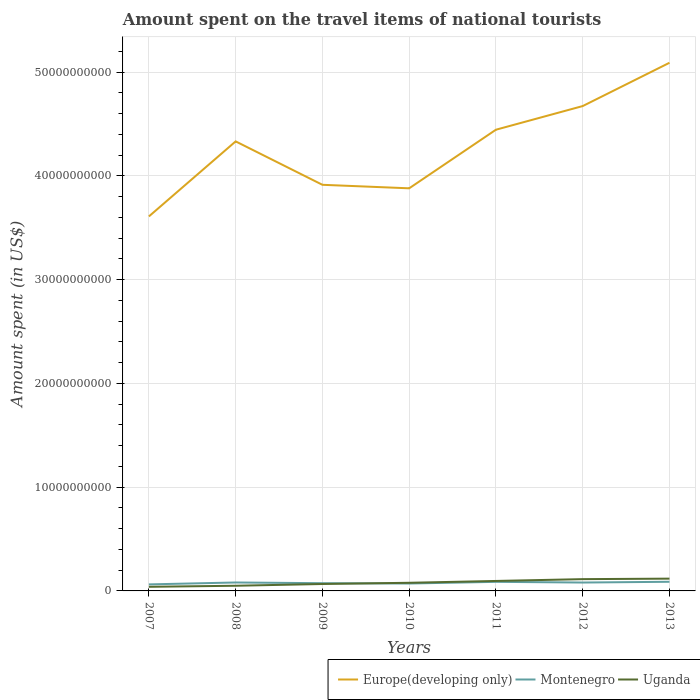Across all years, what is the maximum amount spent on the travel items of national tourists in Uganda?
Provide a short and direct response. 3.98e+08. In which year was the amount spent on the travel items of national tourists in Europe(developing only) maximum?
Provide a succinct answer. 2007. What is the total amount spent on the travel items of national tourists in Montenegro in the graph?
Provide a succinct answer. 6.60e+07. What is the difference between the highest and the second highest amount spent on the travel items of national tourists in Montenegro?
Provide a succinct answer. 2.50e+08. Is the amount spent on the travel items of national tourists in Uganda strictly greater than the amount spent on the travel items of national tourists in Montenegro over the years?
Provide a short and direct response. No. How many lines are there?
Offer a terse response. 3. How many years are there in the graph?
Ensure brevity in your answer.  7. What is the difference between two consecutive major ticks on the Y-axis?
Provide a succinct answer. 1.00e+1. Are the values on the major ticks of Y-axis written in scientific E-notation?
Provide a short and direct response. No. Does the graph contain any zero values?
Give a very brief answer. No. Does the graph contain grids?
Provide a succinct answer. Yes. How are the legend labels stacked?
Provide a short and direct response. Horizontal. What is the title of the graph?
Ensure brevity in your answer.  Amount spent on the travel items of national tourists. What is the label or title of the X-axis?
Provide a succinct answer. Years. What is the label or title of the Y-axis?
Your answer should be compact. Amount spent (in US$). What is the Amount spent (in US$) of Europe(developing only) in 2007?
Ensure brevity in your answer.  3.61e+1. What is the Amount spent (in US$) of Montenegro in 2007?
Your answer should be very brief. 6.30e+08. What is the Amount spent (in US$) in Uganda in 2007?
Offer a terse response. 3.98e+08. What is the Amount spent (in US$) of Europe(developing only) in 2008?
Your answer should be compact. 4.33e+1. What is the Amount spent (in US$) in Montenegro in 2008?
Your answer should be compact. 8.13e+08. What is the Amount spent (in US$) in Uganda in 2008?
Provide a short and direct response. 4.98e+08. What is the Amount spent (in US$) of Europe(developing only) in 2009?
Offer a very short reply. 3.91e+1. What is the Amount spent (in US$) in Montenegro in 2009?
Your answer should be very brief. 7.45e+08. What is the Amount spent (in US$) of Uganda in 2009?
Offer a terse response. 6.67e+08. What is the Amount spent (in US$) of Europe(developing only) in 2010?
Keep it short and to the point. 3.88e+1. What is the Amount spent (in US$) in Montenegro in 2010?
Your response must be concise. 7.13e+08. What is the Amount spent (in US$) of Uganda in 2010?
Offer a very short reply. 7.84e+08. What is the Amount spent (in US$) in Europe(developing only) in 2011?
Offer a terse response. 4.44e+1. What is the Amount spent (in US$) in Montenegro in 2011?
Offer a terse response. 8.75e+08. What is the Amount spent (in US$) of Uganda in 2011?
Provide a succinct answer. 9.60e+08. What is the Amount spent (in US$) of Europe(developing only) in 2012?
Your answer should be compact. 4.67e+1. What is the Amount spent (in US$) of Montenegro in 2012?
Your answer should be compact. 8.09e+08. What is the Amount spent (in US$) in Uganda in 2012?
Your answer should be very brief. 1.14e+09. What is the Amount spent (in US$) in Europe(developing only) in 2013?
Make the answer very short. 5.09e+1. What is the Amount spent (in US$) of Montenegro in 2013?
Ensure brevity in your answer.  8.80e+08. What is the Amount spent (in US$) in Uganda in 2013?
Keep it short and to the point. 1.18e+09. Across all years, what is the maximum Amount spent (in US$) of Europe(developing only)?
Provide a short and direct response. 5.09e+1. Across all years, what is the maximum Amount spent (in US$) in Montenegro?
Your response must be concise. 8.80e+08. Across all years, what is the maximum Amount spent (in US$) in Uganda?
Offer a terse response. 1.18e+09. Across all years, what is the minimum Amount spent (in US$) of Europe(developing only)?
Ensure brevity in your answer.  3.61e+1. Across all years, what is the minimum Amount spent (in US$) in Montenegro?
Give a very brief answer. 6.30e+08. Across all years, what is the minimum Amount spent (in US$) in Uganda?
Offer a very short reply. 3.98e+08. What is the total Amount spent (in US$) in Europe(developing only) in the graph?
Keep it short and to the point. 2.99e+11. What is the total Amount spent (in US$) in Montenegro in the graph?
Your response must be concise. 5.46e+09. What is the total Amount spent (in US$) in Uganda in the graph?
Make the answer very short. 5.63e+09. What is the difference between the Amount spent (in US$) in Europe(developing only) in 2007 and that in 2008?
Keep it short and to the point. -7.23e+09. What is the difference between the Amount spent (in US$) in Montenegro in 2007 and that in 2008?
Ensure brevity in your answer.  -1.83e+08. What is the difference between the Amount spent (in US$) of Uganda in 2007 and that in 2008?
Provide a short and direct response. -1.00e+08. What is the difference between the Amount spent (in US$) in Europe(developing only) in 2007 and that in 2009?
Your response must be concise. -3.05e+09. What is the difference between the Amount spent (in US$) in Montenegro in 2007 and that in 2009?
Ensure brevity in your answer.  -1.15e+08. What is the difference between the Amount spent (in US$) of Uganda in 2007 and that in 2009?
Offer a terse response. -2.69e+08. What is the difference between the Amount spent (in US$) of Europe(developing only) in 2007 and that in 2010?
Give a very brief answer. -2.71e+09. What is the difference between the Amount spent (in US$) of Montenegro in 2007 and that in 2010?
Your answer should be compact. -8.30e+07. What is the difference between the Amount spent (in US$) of Uganda in 2007 and that in 2010?
Offer a very short reply. -3.86e+08. What is the difference between the Amount spent (in US$) of Europe(developing only) in 2007 and that in 2011?
Make the answer very short. -8.36e+09. What is the difference between the Amount spent (in US$) of Montenegro in 2007 and that in 2011?
Keep it short and to the point. -2.45e+08. What is the difference between the Amount spent (in US$) in Uganda in 2007 and that in 2011?
Make the answer very short. -5.62e+08. What is the difference between the Amount spent (in US$) of Europe(developing only) in 2007 and that in 2012?
Your answer should be compact. -1.06e+1. What is the difference between the Amount spent (in US$) in Montenegro in 2007 and that in 2012?
Offer a very short reply. -1.79e+08. What is the difference between the Amount spent (in US$) in Uganda in 2007 and that in 2012?
Offer a very short reply. -7.37e+08. What is the difference between the Amount spent (in US$) of Europe(developing only) in 2007 and that in 2013?
Your response must be concise. -1.48e+1. What is the difference between the Amount spent (in US$) of Montenegro in 2007 and that in 2013?
Your response must be concise. -2.50e+08. What is the difference between the Amount spent (in US$) of Uganda in 2007 and that in 2013?
Your answer should be very brief. -7.86e+08. What is the difference between the Amount spent (in US$) of Europe(developing only) in 2008 and that in 2009?
Offer a terse response. 4.18e+09. What is the difference between the Amount spent (in US$) of Montenegro in 2008 and that in 2009?
Make the answer very short. 6.80e+07. What is the difference between the Amount spent (in US$) of Uganda in 2008 and that in 2009?
Your answer should be very brief. -1.69e+08. What is the difference between the Amount spent (in US$) of Europe(developing only) in 2008 and that in 2010?
Make the answer very short. 4.52e+09. What is the difference between the Amount spent (in US$) of Montenegro in 2008 and that in 2010?
Your response must be concise. 1.00e+08. What is the difference between the Amount spent (in US$) of Uganda in 2008 and that in 2010?
Your answer should be compact. -2.86e+08. What is the difference between the Amount spent (in US$) in Europe(developing only) in 2008 and that in 2011?
Your response must be concise. -1.12e+09. What is the difference between the Amount spent (in US$) of Montenegro in 2008 and that in 2011?
Your response must be concise. -6.20e+07. What is the difference between the Amount spent (in US$) in Uganda in 2008 and that in 2011?
Your response must be concise. -4.62e+08. What is the difference between the Amount spent (in US$) in Europe(developing only) in 2008 and that in 2012?
Make the answer very short. -3.40e+09. What is the difference between the Amount spent (in US$) in Uganda in 2008 and that in 2012?
Your answer should be very brief. -6.37e+08. What is the difference between the Amount spent (in US$) of Europe(developing only) in 2008 and that in 2013?
Provide a short and direct response. -7.57e+09. What is the difference between the Amount spent (in US$) in Montenegro in 2008 and that in 2013?
Provide a short and direct response. -6.70e+07. What is the difference between the Amount spent (in US$) in Uganda in 2008 and that in 2013?
Offer a very short reply. -6.86e+08. What is the difference between the Amount spent (in US$) of Europe(developing only) in 2009 and that in 2010?
Offer a terse response. 3.38e+08. What is the difference between the Amount spent (in US$) of Montenegro in 2009 and that in 2010?
Ensure brevity in your answer.  3.20e+07. What is the difference between the Amount spent (in US$) of Uganda in 2009 and that in 2010?
Make the answer very short. -1.17e+08. What is the difference between the Amount spent (in US$) of Europe(developing only) in 2009 and that in 2011?
Make the answer very short. -5.31e+09. What is the difference between the Amount spent (in US$) in Montenegro in 2009 and that in 2011?
Your answer should be compact. -1.30e+08. What is the difference between the Amount spent (in US$) of Uganda in 2009 and that in 2011?
Offer a terse response. -2.93e+08. What is the difference between the Amount spent (in US$) of Europe(developing only) in 2009 and that in 2012?
Provide a succinct answer. -7.59e+09. What is the difference between the Amount spent (in US$) of Montenegro in 2009 and that in 2012?
Your answer should be very brief. -6.40e+07. What is the difference between the Amount spent (in US$) in Uganda in 2009 and that in 2012?
Keep it short and to the point. -4.68e+08. What is the difference between the Amount spent (in US$) of Europe(developing only) in 2009 and that in 2013?
Your answer should be compact. -1.18e+1. What is the difference between the Amount spent (in US$) of Montenegro in 2009 and that in 2013?
Provide a short and direct response. -1.35e+08. What is the difference between the Amount spent (in US$) in Uganda in 2009 and that in 2013?
Give a very brief answer. -5.17e+08. What is the difference between the Amount spent (in US$) of Europe(developing only) in 2010 and that in 2011?
Your answer should be very brief. -5.65e+09. What is the difference between the Amount spent (in US$) in Montenegro in 2010 and that in 2011?
Provide a short and direct response. -1.62e+08. What is the difference between the Amount spent (in US$) in Uganda in 2010 and that in 2011?
Ensure brevity in your answer.  -1.76e+08. What is the difference between the Amount spent (in US$) in Europe(developing only) in 2010 and that in 2012?
Offer a very short reply. -7.92e+09. What is the difference between the Amount spent (in US$) in Montenegro in 2010 and that in 2012?
Offer a very short reply. -9.60e+07. What is the difference between the Amount spent (in US$) in Uganda in 2010 and that in 2012?
Provide a succinct answer. -3.51e+08. What is the difference between the Amount spent (in US$) in Europe(developing only) in 2010 and that in 2013?
Keep it short and to the point. -1.21e+1. What is the difference between the Amount spent (in US$) of Montenegro in 2010 and that in 2013?
Provide a short and direct response. -1.67e+08. What is the difference between the Amount spent (in US$) in Uganda in 2010 and that in 2013?
Offer a very short reply. -4.00e+08. What is the difference between the Amount spent (in US$) in Europe(developing only) in 2011 and that in 2012?
Offer a very short reply. -2.28e+09. What is the difference between the Amount spent (in US$) in Montenegro in 2011 and that in 2012?
Provide a succinct answer. 6.60e+07. What is the difference between the Amount spent (in US$) in Uganda in 2011 and that in 2012?
Make the answer very short. -1.75e+08. What is the difference between the Amount spent (in US$) in Europe(developing only) in 2011 and that in 2013?
Offer a very short reply. -6.45e+09. What is the difference between the Amount spent (in US$) in Montenegro in 2011 and that in 2013?
Your response must be concise. -5.00e+06. What is the difference between the Amount spent (in US$) of Uganda in 2011 and that in 2013?
Offer a terse response. -2.24e+08. What is the difference between the Amount spent (in US$) of Europe(developing only) in 2012 and that in 2013?
Your answer should be compact. -4.17e+09. What is the difference between the Amount spent (in US$) in Montenegro in 2012 and that in 2013?
Provide a short and direct response. -7.10e+07. What is the difference between the Amount spent (in US$) of Uganda in 2012 and that in 2013?
Provide a succinct answer. -4.90e+07. What is the difference between the Amount spent (in US$) in Europe(developing only) in 2007 and the Amount spent (in US$) in Montenegro in 2008?
Your response must be concise. 3.53e+1. What is the difference between the Amount spent (in US$) of Europe(developing only) in 2007 and the Amount spent (in US$) of Uganda in 2008?
Make the answer very short. 3.56e+1. What is the difference between the Amount spent (in US$) in Montenegro in 2007 and the Amount spent (in US$) in Uganda in 2008?
Make the answer very short. 1.32e+08. What is the difference between the Amount spent (in US$) in Europe(developing only) in 2007 and the Amount spent (in US$) in Montenegro in 2009?
Give a very brief answer. 3.53e+1. What is the difference between the Amount spent (in US$) of Europe(developing only) in 2007 and the Amount spent (in US$) of Uganda in 2009?
Your answer should be compact. 3.54e+1. What is the difference between the Amount spent (in US$) in Montenegro in 2007 and the Amount spent (in US$) in Uganda in 2009?
Provide a succinct answer. -3.70e+07. What is the difference between the Amount spent (in US$) in Europe(developing only) in 2007 and the Amount spent (in US$) in Montenegro in 2010?
Give a very brief answer. 3.54e+1. What is the difference between the Amount spent (in US$) in Europe(developing only) in 2007 and the Amount spent (in US$) in Uganda in 2010?
Provide a short and direct response. 3.53e+1. What is the difference between the Amount spent (in US$) in Montenegro in 2007 and the Amount spent (in US$) in Uganda in 2010?
Make the answer very short. -1.54e+08. What is the difference between the Amount spent (in US$) in Europe(developing only) in 2007 and the Amount spent (in US$) in Montenegro in 2011?
Provide a short and direct response. 3.52e+1. What is the difference between the Amount spent (in US$) of Europe(developing only) in 2007 and the Amount spent (in US$) of Uganda in 2011?
Make the answer very short. 3.51e+1. What is the difference between the Amount spent (in US$) of Montenegro in 2007 and the Amount spent (in US$) of Uganda in 2011?
Give a very brief answer. -3.30e+08. What is the difference between the Amount spent (in US$) in Europe(developing only) in 2007 and the Amount spent (in US$) in Montenegro in 2012?
Offer a very short reply. 3.53e+1. What is the difference between the Amount spent (in US$) of Europe(developing only) in 2007 and the Amount spent (in US$) of Uganda in 2012?
Offer a very short reply. 3.49e+1. What is the difference between the Amount spent (in US$) of Montenegro in 2007 and the Amount spent (in US$) of Uganda in 2012?
Offer a very short reply. -5.05e+08. What is the difference between the Amount spent (in US$) in Europe(developing only) in 2007 and the Amount spent (in US$) in Montenegro in 2013?
Ensure brevity in your answer.  3.52e+1. What is the difference between the Amount spent (in US$) of Europe(developing only) in 2007 and the Amount spent (in US$) of Uganda in 2013?
Offer a very short reply. 3.49e+1. What is the difference between the Amount spent (in US$) in Montenegro in 2007 and the Amount spent (in US$) in Uganda in 2013?
Offer a terse response. -5.54e+08. What is the difference between the Amount spent (in US$) in Europe(developing only) in 2008 and the Amount spent (in US$) in Montenegro in 2009?
Give a very brief answer. 4.26e+1. What is the difference between the Amount spent (in US$) in Europe(developing only) in 2008 and the Amount spent (in US$) in Uganda in 2009?
Provide a short and direct response. 4.26e+1. What is the difference between the Amount spent (in US$) in Montenegro in 2008 and the Amount spent (in US$) in Uganda in 2009?
Make the answer very short. 1.46e+08. What is the difference between the Amount spent (in US$) in Europe(developing only) in 2008 and the Amount spent (in US$) in Montenegro in 2010?
Ensure brevity in your answer.  4.26e+1. What is the difference between the Amount spent (in US$) of Europe(developing only) in 2008 and the Amount spent (in US$) of Uganda in 2010?
Keep it short and to the point. 4.25e+1. What is the difference between the Amount spent (in US$) of Montenegro in 2008 and the Amount spent (in US$) of Uganda in 2010?
Offer a terse response. 2.90e+07. What is the difference between the Amount spent (in US$) in Europe(developing only) in 2008 and the Amount spent (in US$) in Montenegro in 2011?
Keep it short and to the point. 4.24e+1. What is the difference between the Amount spent (in US$) in Europe(developing only) in 2008 and the Amount spent (in US$) in Uganda in 2011?
Keep it short and to the point. 4.24e+1. What is the difference between the Amount spent (in US$) of Montenegro in 2008 and the Amount spent (in US$) of Uganda in 2011?
Provide a short and direct response. -1.47e+08. What is the difference between the Amount spent (in US$) of Europe(developing only) in 2008 and the Amount spent (in US$) of Montenegro in 2012?
Make the answer very short. 4.25e+1. What is the difference between the Amount spent (in US$) in Europe(developing only) in 2008 and the Amount spent (in US$) in Uganda in 2012?
Make the answer very short. 4.22e+1. What is the difference between the Amount spent (in US$) of Montenegro in 2008 and the Amount spent (in US$) of Uganda in 2012?
Provide a short and direct response. -3.22e+08. What is the difference between the Amount spent (in US$) in Europe(developing only) in 2008 and the Amount spent (in US$) in Montenegro in 2013?
Provide a short and direct response. 4.24e+1. What is the difference between the Amount spent (in US$) of Europe(developing only) in 2008 and the Amount spent (in US$) of Uganda in 2013?
Keep it short and to the point. 4.21e+1. What is the difference between the Amount spent (in US$) in Montenegro in 2008 and the Amount spent (in US$) in Uganda in 2013?
Keep it short and to the point. -3.71e+08. What is the difference between the Amount spent (in US$) in Europe(developing only) in 2009 and the Amount spent (in US$) in Montenegro in 2010?
Give a very brief answer. 3.84e+1. What is the difference between the Amount spent (in US$) of Europe(developing only) in 2009 and the Amount spent (in US$) of Uganda in 2010?
Your response must be concise. 3.83e+1. What is the difference between the Amount spent (in US$) of Montenegro in 2009 and the Amount spent (in US$) of Uganda in 2010?
Offer a terse response. -3.90e+07. What is the difference between the Amount spent (in US$) of Europe(developing only) in 2009 and the Amount spent (in US$) of Montenegro in 2011?
Your response must be concise. 3.83e+1. What is the difference between the Amount spent (in US$) in Europe(developing only) in 2009 and the Amount spent (in US$) in Uganda in 2011?
Ensure brevity in your answer.  3.82e+1. What is the difference between the Amount spent (in US$) of Montenegro in 2009 and the Amount spent (in US$) of Uganda in 2011?
Provide a short and direct response. -2.15e+08. What is the difference between the Amount spent (in US$) of Europe(developing only) in 2009 and the Amount spent (in US$) of Montenegro in 2012?
Give a very brief answer. 3.83e+1. What is the difference between the Amount spent (in US$) of Europe(developing only) in 2009 and the Amount spent (in US$) of Uganda in 2012?
Your response must be concise. 3.80e+1. What is the difference between the Amount spent (in US$) of Montenegro in 2009 and the Amount spent (in US$) of Uganda in 2012?
Offer a terse response. -3.90e+08. What is the difference between the Amount spent (in US$) in Europe(developing only) in 2009 and the Amount spent (in US$) in Montenegro in 2013?
Keep it short and to the point. 3.83e+1. What is the difference between the Amount spent (in US$) in Europe(developing only) in 2009 and the Amount spent (in US$) in Uganda in 2013?
Give a very brief answer. 3.79e+1. What is the difference between the Amount spent (in US$) in Montenegro in 2009 and the Amount spent (in US$) in Uganda in 2013?
Offer a very short reply. -4.39e+08. What is the difference between the Amount spent (in US$) in Europe(developing only) in 2010 and the Amount spent (in US$) in Montenegro in 2011?
Your answer should be very brief. 3.79e+1. What is the difference between the Amount spent (in US$) of Europe(developing only) in 2010 and the Amount spent (in US$) of Uganda in 2011?
Keep it short and to the point. 3.78e+1. What is the difference between the Amount spent (in US$) in Montenegro in 2010 and the Amount spent (in US$) in Uganda in 2011?
Your answer should be very brief. -2.47e+08. What is the difference between the Amount spent (in US$) of Europe(developing only) in 2010 and the Amount spent (in US$) of Montenegro in 2012?
Your answer should be compact. 3.80e+1. What is the difference between the Amount spent (in US$) in Europe(developing only) in 2010 and the Amount spent (in US$) in Uganda in 2012?
Give a very brief answer. 3.77e+1. What is the difference between the Amount spent (in US$) in Montenegro in 2010 and the Amount spent (in US$) in Uganda in 2012?
Your response must be concise. -4.22e+08. What is the difference between the Amount spent (in US$) of Europe(developing only) in 2010 and the Amount spent (in US$) of Montenegro in 2013?
Your answer should be compact. 3.79e+1. What is the difference between the Amount spent (in US$) of Europe(developing only) in 2010 and the Amount spent (in US$) of Uganda in 2013?
Make the answer very short. 3.76e+1. What is the difference between the Amount spent (in US$) in Montenegro in 2010 and the Amount spent (in US$) in Uganda in 2013?
Your answer should be very brief. -4.71e+08. What is the difference between the Amount spent (in US$) in Europe(developing only) in 2011 and the Amount spent (in US$) in Montenegro in 2012?
Offer a very short reply. 4.36e+1. What is the difference between the Amount spent (in US$) of Europe(developing only) in 2011 and the Amount spent (in US$) of Uganda in 2012?
Your response must be concise. 4.33e+1. What is the difference between the Amount spent (in US$) in Montenegro in 2011 and the Amount spent (in US$) in Uganda in 2012?
Give a very brief answer. -2.60e+08. What is the difference between the Amount spent (in US$) of Europe(developing only) in 2011 and the Amount spent (in US$) of Montenegro in 2013?
Ensure brevity in your answer.  4.36e+1. What is the difference between the Amount spent (in US$) in Europe(developing only) in 2011 and the Amount spent (in US$) in Uganda in 2013?
Provide a short and direct response. 4.33e+1. What is the difference between the Amount spent (in US$) in Montenegro in 2011 and the Amount spent (in US$) in Uganda in 2013?
Keep it short and to the point. -3.09e+08. What is the difference between the Amount spent (in US$) in Europe(developing only) in 2012 and the Amount spent (in US$) in Montenegro in 2013?
Give a very brief answer. 4.58e+1. What is the difference between the Amount spent (in US$) of Europe(developing only) in 2012 and the Amount spent (in US$) of Uganda in 2013?
Ensure brevity in your answer.  4.55e+1. What is the difference between the Amount spent (in US$) of Montenegro in 2012 and the Amount spent (in US$) of Uganda in 2013?
Keep it short and to the point. -3.75e+08. What is the average Amount spent (in US$) of Europe(developing only) per year?
Your response must be concise. 4.28e+1. What is the average Amount spent (in US$) of Montenegro per year?
Provide a succinct answer. 7.81e+08. What is the average Amount spent (in US$) in Uganda per year?
Make the answer very short. 8.04e+08. In the year 2007, what is the difference between the Amount spent (in US$) of Europe(developing only) and Amount spent (in US$) of Montenegro?
Provide a succinct answer. 3.55e+1. In the year 2007, what is the difference between the Amount spent (in US$) of Europe(developing only) and Amount spent (in US$) of Uganda?
Offer a very short reply. 3.57e+1. In the year 2007, what is the difference between the Amount spent (in US$) in Montenegro and Amount spent (in US$) in Uganda?
Your response must be concise. 2.32e+08. In the year 2008, what is the difference between the Amount spent (in US$) in Europe(developing only) and Amount spent (in US$) in Montenegro?
Your answer should be compact. 4.25e+1. In the year 2008, what is the difference between the Amount spent (in US$) of Europe(developing only) and Amount spent (in US$) of Uganda?
Keep it short and to the point. 4.28e+1. In the year 2008, what is the difference between the Amount spent (in US$) in Montenegro and Amount spent (in US$) in Uganda?
Provide a succinct answer. 3.15e+08. In the year 2009, what is the difference between the Amount spent (in US$) in Europe(developing only) and Amount spent (in US$) in Montenegro?
Your response must be concise. 3.84e+1. In the year 2009, what is the difference between the Amount spent (in US$) in Europe(developing only) and Amount spent (in US$) in Uganda?
Offer a terse response. 3.85e+1. In the year 2009, what is the difference between the Amount spent (in US$) of Montenegro and Amount spent (in US$) of Uganda?
Provide a short and direct response. 7.80e+07. In the year 2010, what is the difference between the Amount spent (in US$) of Europe(developing only) and Amount spent (in US$) of Montenegro?
Offer a terse response. 3.81e+1. In the year 2010, what is the difference between the Amount spent (in US$) of Europe(developing only) and Amount spent (in US$) of Uganda?
Give a very brief answer. 3.80e+1. In the year 2010, what is the difference between the Amount spent (in US$) of Montenegro and Amount spent (in US$) of Uganda?
Offer a very short reply. -7.10e+07. In the year 2011, what is the difference between the Amount spent (in US$) in Europe(developing only) and Amount spent (in US$) in Montenegro?
Offer a very short reply. 4.36e+1. In the year 2011, what is the difference between the Amount spent (in US$) of Europe(developing only) and Amount spent (in US$) of Uganda?
Offer a terse response. 4.35e+1. In the year 2011, what is the difference between the Amount spent (in US$) of Montenegro and Amount spent (in US$) of Uganda?
Keep it short and to the point. -8.50e+07. In the year 2012, what is the difference between the Amount spent (in US$) of Europe(developing only) and Amount spent (in US$) of Montenegro?
Make the answer very short. 4.59e+1. In the year 2012, what is the difference between the Amount spent (in US$) in Europe(developing only) and Amount spent (in US$) in Uganda?
Offer a terse response. 4.56e+1. In the year 2012, what is the difference between the Amount spent (in US$) in Montenegro and Amount spent (in US$) in Uganda?
Your answer should be very brief. -3.26e+08. In the year 2013, what is the difference between the Amount spent (in US$) in Europe(developing only) and Amount spent (in US$) in Montenegro?
Provide a succinct answer. 5.00e+1. In the year 2013, what is the difference between the Amount spent (in US$) in Europe(developing only) and Amount spent (in US$) in Uganda?
Make the answer very short. 4.97e+1. In the year 2013, what is the difference between the Amount spent (in US$) in Montenegro and Amount spent (in US$) in Uganda?
Your answer should be compact. -3.04e+08. What is the ratio of the Amount spent (in US$) of Europe(developing only) in 2007 to that in 2008?
Provide a short and direct response. 0.83. What is the ratio of the Amount spent (in US$) in Montenegro in 2007 to that in 2008?
Make the answer very short. 0.77. What is the ratio of the Amount spent (in US$) in Uganda in 2007 to that in 2008?
Make the answer very short. 0.8. What is the ratio of the Amount spent (in US$) of Europe(developing only) in 2007 to that in 2009?
Your answer should be very brief. 0.92. What is the ratio of the Amount spent (in US$) of Montenegro in 2007 to that in 2009?
Your response must be concise. 0.85. What is the ratio of the Amount spent (in US$) of Uganda in 2007 to that in 2009?
Your answer should be compact. 0.6. What is the ratio of the Amount spent (in US$) in Europe(developing only) in 2007 to that in 2010?
Keep it short and to the point. 0.93. What is the ratio of the Amount spent (in US$) of Montenegro in 2007 to that in 2010?
Give a very brief answer. 0.88. What is the ratio of the Amount spent (in US$) in Uganda in 2007 to that in 2010?
Your response must be concise. 0.51. What is the ratio of the Amount spent (in US$) of Europe(developing only) in 2007 to that in 2011?
Provide a short and direct response. 0.81. What is the ratio of the Amount spent (in US$) in Montenegro in 2007 to that in 2011?
Make the answer very short. 0.72. What is the ratio of the Amount spent (in US$) in Uganda in 2007 to that in 2011?
Your answer should be very brief. 0.41. What is the ratio of the Amount spent (in US$) in Europe(developing only) in 2007 to that in 2012?
Provide a short and direct response. 0.77. What is the ratio of the Amount spent (in US$) of Montenegro in 2007 to that in 2012?
Keep it short and to the point. 0.78. What is the ratio of the Amount spent (in US$) in Uganda in 2007 to that in 2012?
Your answer should be compact. 0.35. What is the ratio of the Amount spent (in US$) in Europe(developing only) in 2007 to that in 2013?
Provide a succinct answer. 0.71. What is the ratio of the Amount spent (in US$) in Montenegro in 2007 to that in 2013?
Offer a terse response. 0.72. What is the ratio of the Amount spent (in US$) of Uganda in 2007 to that in 2013?
Provide a succinct answer. 0.34. What is the ratio of the Amount spent (in US$) of Europe(developing only) in 2008 to that in 2009?
Offer a terse response. 1.11. What is the ratio of the Amount spent (in US$) in Montenegro in 2008 to that in 2009?
Offer a very short reply. 1.09. What is the ratio of the Amount spent (in US$) in Uganda in 2008 to that in 2009?
Your answer should be very brief. 0.75. What is the ratio of the Amount spent (in US$) in Europe(developing only) in 2008 to that in 2010?
Offer a terse response. 1.12. What is the ratio of the Amount spent (in US$) of Montenegro in 2008 to that in 2010?
Your answer should be very brief. 1.14. What is the ratio of the Amount spent (in US$) of Uganda in 2008 to that in 2010?
Give a very brief answer. 0.64. What is the ratio of the Amount spent (in US$) of Europe(developing only) in 2008 to that in 2011?
Your answer should be very brief. 0.97. What is the ratio of the Amount spent (in US$) in Montenegro in 2008 to that in 2011?
Make the answer very short. 0.93. What is the ratio of the Amount spent (in US$) of Uganda in 2008 to that in 2011?
Keep it short and to the point. 0.52. What is the ratio of the Amount spent (in US$) in Europe(developing only) in 2008 to that in 2012?
Provide a short and direct response. 0.93. What is the ratio of the Amount spent (in US$) in Uganda in 2008 to that in 2012?
Offer a very short reply. 0.44. What is the ratio of the Amount spent (in US$) in Europe(developing only) in 2008 to that in 2013?
Keep it short and to the point. 0.85. What is the ratio of the Amount spent (in US$) of Montenegro in 2008 to that in 2013?
Ensure brevity in your answer.  0.92. What is the ratio of the Amount spent (in US$) in Uganda in 2008 to that in 2013?
Make the answer very short. 0.42. What is the ratio of the Amount spent (in US$) in Europe(developing only) in 2009 to that in 2010?
Your answer should be very brief. 1.01. What is the ratio of the Amount spent (in US$) of Montenegro in 2009 to that in 2010?
Your response must be concise. 1.04. What is the ratio of the Amount spent (in US$) in Uganda in 2009 to that in 2010?
Your response must be concise. 0.85. What is the ratio of the Amount spent (in US$) in Europe(developing only) in 2009 to that in 2011?
Your answer should be very brief. 0.88. What is the ratio of the Amount spent (in US$) of Montenegro in 2009 to that in 2011?
Ensure brevity in your answer.  0.85. What is the ratio of the Amount spent (in US$) of Uganda in 2009 to that in 2011?
Offer a terse response. 0.69. What is the ratio of the Amount spent (in US$) of Europe(developing only) in 2009 to that in 2012?
Provide a succinct answer. 0.84. What is the ratio of the Amount spent (in US$) of Montenegro in 2009 to that in 2012?
Your answer should be compact. 0.92. What is the ratio of the Amount spent (in US$) of Uganda in 2009 to that in 2012?
Provide a succinct answer. 0.59. What is the ratio of the Amount spent (in US$) of Europe(developing only) in 2009 to that in 2013?
Ensure brevity in your answer.  0.77. What is the ratio of the Amount spent (in US$) of Montenegro in 2009 to that in 2013?
Provide a succinct answer. 0.85. What is the ratio of the Amount spent (in US$) in Uganda in 2009 to that in 2013?
Offer a very short reply. 0.56. What is the ratio of the Amount spent (in US$) of Europe(developing only) in 2010 to that in 2011?
Ensure brevity in your answer.  0.87. What is the ratio of the Amount spent (in US$) in Montenegro in 2010 to that in 2011?
Provide a succinct answer. 0.81. What is the ratio of the Amount spent (in US$) of Uganda in 2010 to that in 2011?
Provide a short and direct response. 0.82. What is the ratio of the Amount spent (in US$) of Europe(developing only) in 2010 to that in 2012?
Offer a very short reply. 0.83. What is the ratio of the Amount spent (in US$) of Montenegro in 2010 to that in 2012?
Keep it short and to the point. 0.88. What is the ratio of the Amount spent (in US$) of Uganda in 2010 to that in 2012?
Your answer should be compact. 0.69. What is the ratio of the Amount spent (in US$) in Europe(developing only) in 2010 to that in 2013?
Keep it short and to the point. 0.76. What is the ratio of the Amount spent (in US$) in Montenegro in 2010 to that in 2013?
Your answer should be very brief. 0.81. What is the ratio of the Amount spent (in US$) in Uganda in 2010 to that in 2013?
Your answer should be compact. 0.66. What is the ratio of the Amount spent (in US$) of Europe(developing only) in 2011 to that in 2012?
Your answer should be very brief. 0.95. What is the ratio of the Amount spent (in US$) in Montenegro in 2011 to that in 2012?
Keep it short and to the point. 1.08. What is the ratio of the Amount spent (in US$) of Uganda in 2011 to that in 2012?
Your answer should be compact. 0.85. What is the ratio of the Amount spent (in US$) of Europe(developing only) in 2011 to that in 2013?
Your response must be concise. 0.87. What is the ratio of the Amount spent (in US$) in Montenegro in 2011 to that in 2013?
Give a very brief answer. 0.99. What is the ratio of the Amount spent (in US$) of Uganda in 2011 to that in 2013?
Provide a short and direct response. 0.81. What is the ratio of the Amount spent (in US$) in Europe(developing only) in 2012 to that in 2013?
Ensure brevity in your answer.  0.92. What is the ratio of the Amount spent (in US$) in Montenegro in 2012 to that in 2013?
Your answer should be compact. 0.92. What is the ratio of the Amount spent (in US$) in Uganda in 2012 to that in 2013?
Your response must be concise. 0.96. What is the difference between the highest and the second highest Amount spent (in US$) in Europe(developing only)?
Keep it short and to the point. 4.17e+09. What is the difference between the highest and the second highest Amount spent (in US$) of Montenegro?
Your response must be concise. 5.00e+06. What is the difference between the highest and the second highest Amount spent (in US$) in Uganda?
Provide a short and direct response. 4.90e+07. What is the difference between the highest and the lowest Amount spent (in US$) of Europe(developing only)?
Make the answer very short. 1.48e+1. What is the difference between the highest and the lowest Amount spent (in US$) in Montenegro?
Your answer should be very brief. 2.50e+08. What is the difference between the highest and the lowest Amount spent (in US$) in Uganda?
Offer a terse response. 7.86e+08. 